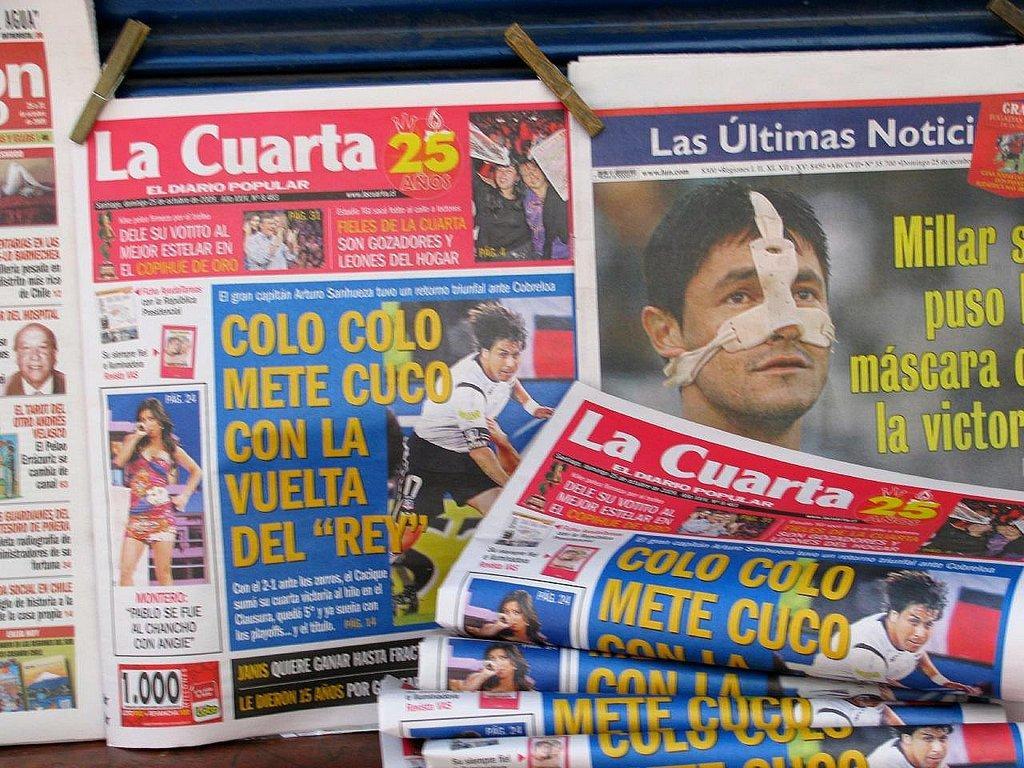Could you give a brief overview of what you see in this image? In this image, we can see pictures of a people printed on the newspapers and there is some text and logos and there are holders. 